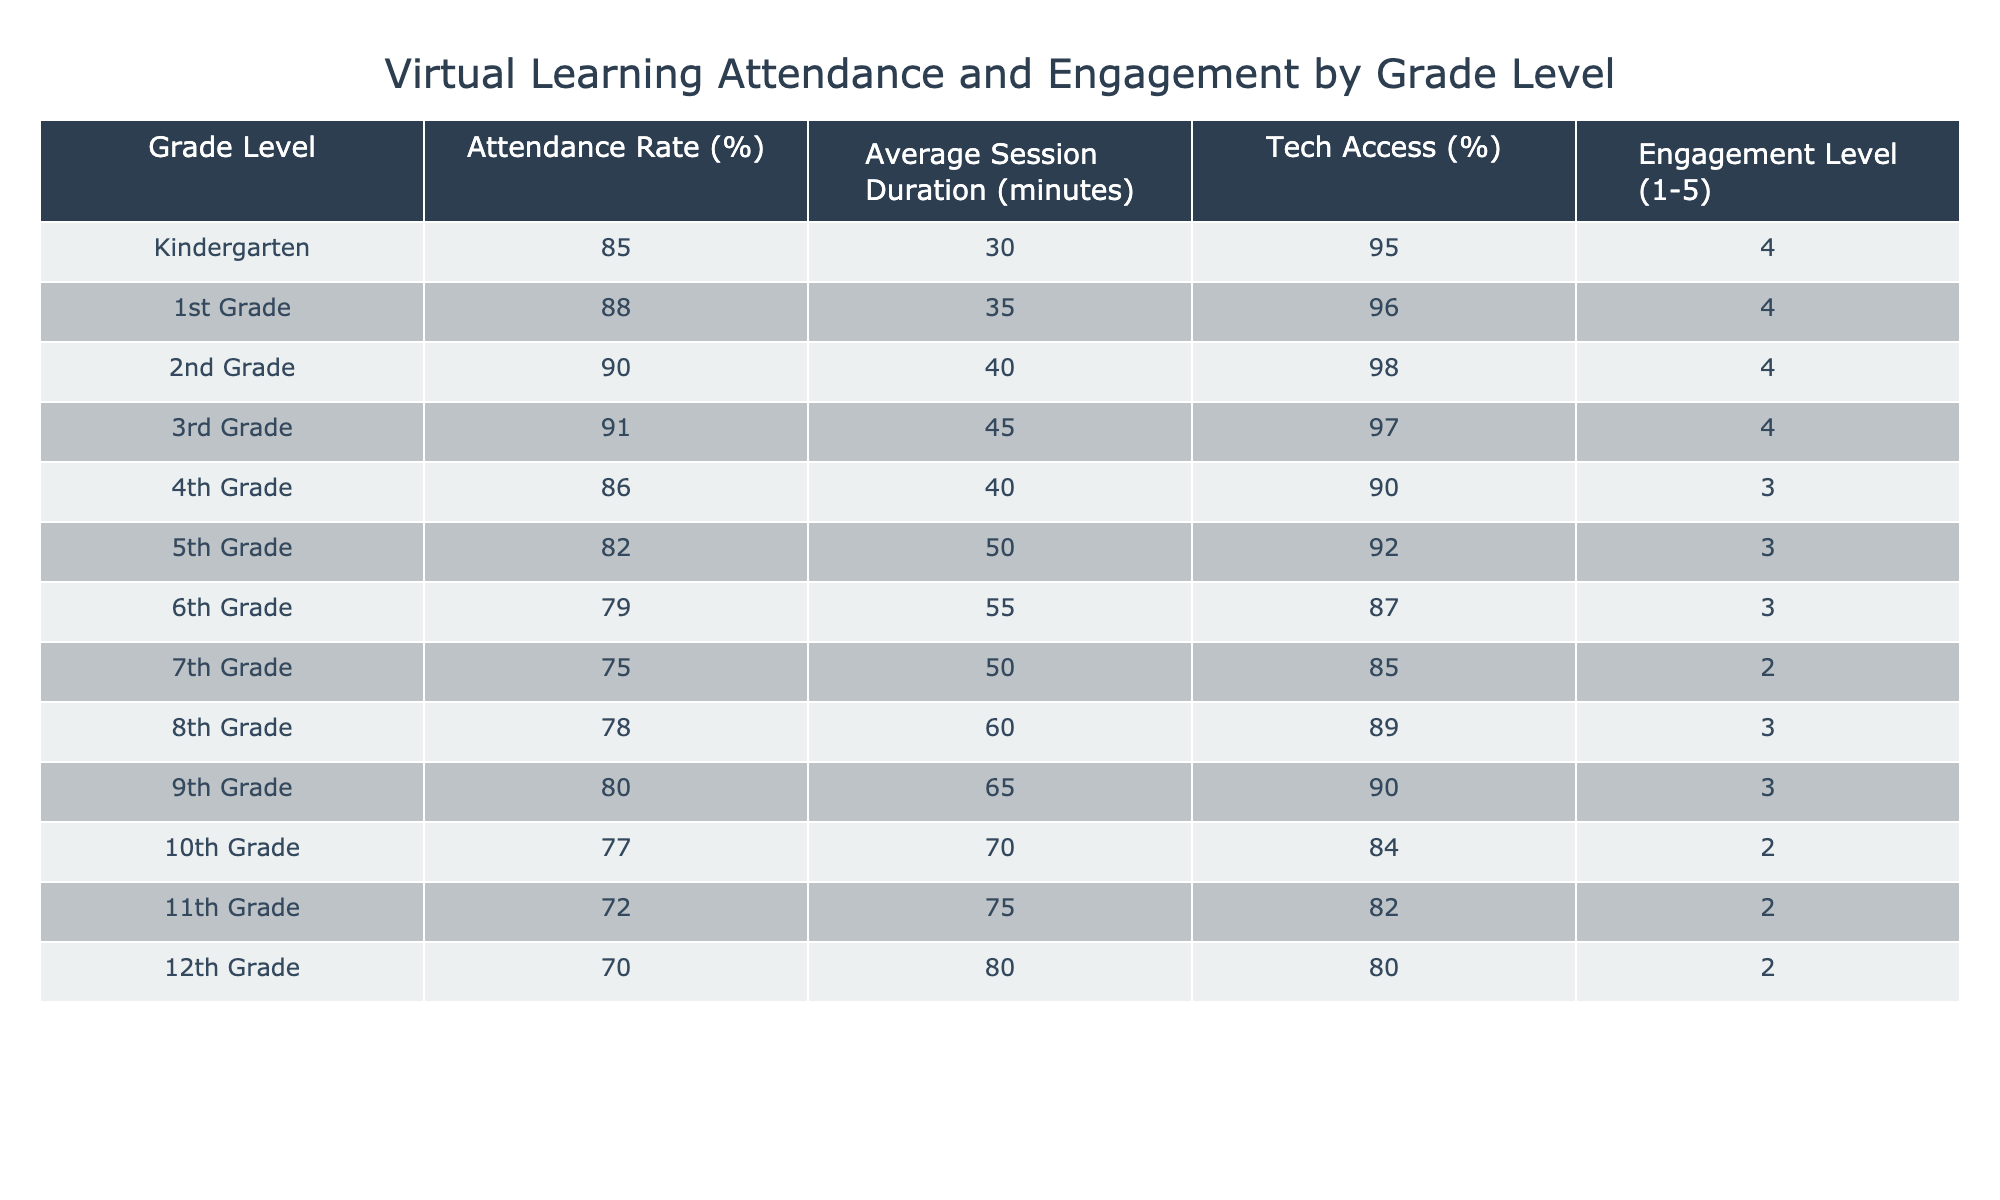What is the attendance rate for 3rd Grade? The table lists the attendance rates for each grade level. For 3rd Grade, the attendance rate is explicitly mentioned as 91%.
Answer: 91% Which grade level has the highest average session duration? The average session duration for each grade level is provided in the table. By comparing these values, 12th Grade has the highest average session duration at 80 minutes.
Answer: 12th Grade Is the tech access percentage lower in 7th Grade compared to 8th Grade? The tech access percentages for 7th and 8th Grade are 85% and 89%, respectively. Since 85% is lower than 89%, the answer is yes.
Answer: Yes What is the average attendance rate for grades 9 to 12? The attendance rates for grades 9 to 12 are 80%, 77%, 72%, and 70%. To find the average, sum them up: 80 + 77 + 72 + 70 = 299, then divide by 4 to get 74.75%.
Answer: 74.75% Does any grade level have an engagement level of 5? The engagement levels for all grade levels are listed in the table. None of the grades have an engagement level of 5; the highest recorded level is 4.
Answer: No Which grade level has the lowest tech access percentage and what is that percentage? From the table, 12th Grade has the lowest tech access percentage at 80%.
Answer: 80% Calculate the difference in engagement levels between 6th Grade and 3rd Grade. The engagement level for 6th Grade is 3, and for 3rd Grade, it is 4. The difference is calculated as 4 - 3 = 1.
Answer: 1 Which grade level has a higher attendance rate, 1st Grade or 4th Grade? 1st Grade has an attendance rate of 88% while 4th Grade has an attendance rate of 86%. Since 88% is greater than 86%, 1st Grade has a higher attendance rate.
Answer: 1st Grade What is the total attendance rate for grades 5 and 6 combined? The attendance rates for grades 5 and 6 are 82% and 79%, respectively. Summing these gives 82 + 79 = 161%. The total attendance rate for these grades combined is 161%.
Answer: 161% 